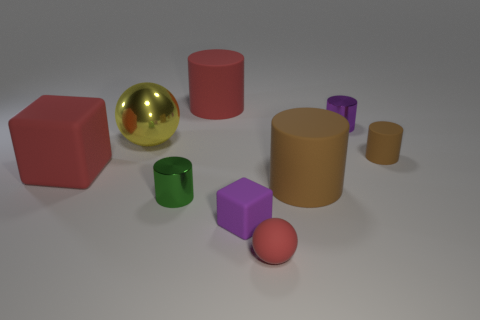There is a green metal object; are there any metallic objects in front of it?
Offer a very short reply. No. What color is the cylinder to the right of the tiny metallic thing that is right of the big red object that is behind the large yellow ball?
Provide a succinct answer. Brown. What shape is the red object that is the same size as the green cylinder?
Ensure brevity in your answer.  Sphere. Are there more blue blocks than tiny green cylinders?
Your answer should be compact. No. There is a small rubber thing behind the green object; are there any yellow things that are behind it?
Provide a succinct answer. Yes. What is the color of the other metallic thing that is the same shape as the tiny green object?
Ensure brevity in your answer.  Purple. Is there any other thing that is the same shape as the purple matte thing?
Make the answer very short. Yes. There is a small cylinder that is the same material as the small red object; what is its color?
Provide a succinct answer. Brown. There is a big red rubber object that is behind the purple thing behind the purple rubber block; are there any yellow things right of it?
Keep it short and to the point. No. Is the number of small purple shiny cylinders that are to the right of the metallic ball less than the number of big cylinders that are to the left of the tiny green cylinder?
Ensure brevity in your answer.  No. 